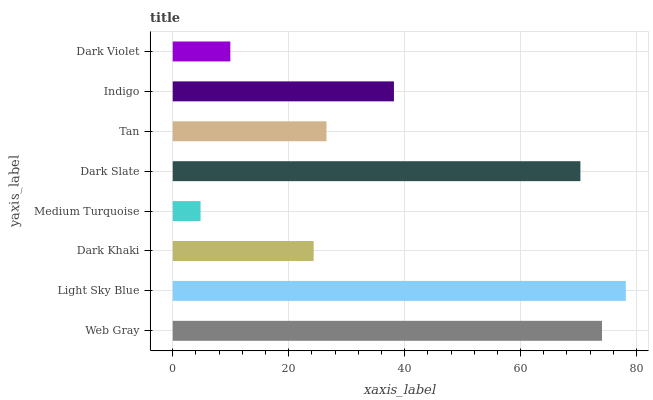Is Medium Turquoise the minimum?
Answer yes or no. Yes. Is Light Sky Blue the maximum?
Answer yes or no. Yes. Is Dark Khaki the minimum?
Answer yes or no. No. Is Dark Khaki the maximum?
Answer yes or no. No. Is Light Sky Blue greater than Dark Khaki?
Answer yes or no. Yes. Is Dark Khaki less than Light Sky Blue?
Answer yes or no. Yes. Is Dark Khaki greater than Light Sky Blue?
Answer yes or no. No. Is Light Sky Blue less than Dark Khaki?
Answer yes or no. No. Is Indigo the high median?
Answer yes or no. Yes. Is Tan the low median?
Answer yes or no. Yes. Is Dark Violet the high median?
Answer yes or no. No. Is Dark Violet the low median?
Answer yes or no. No. 